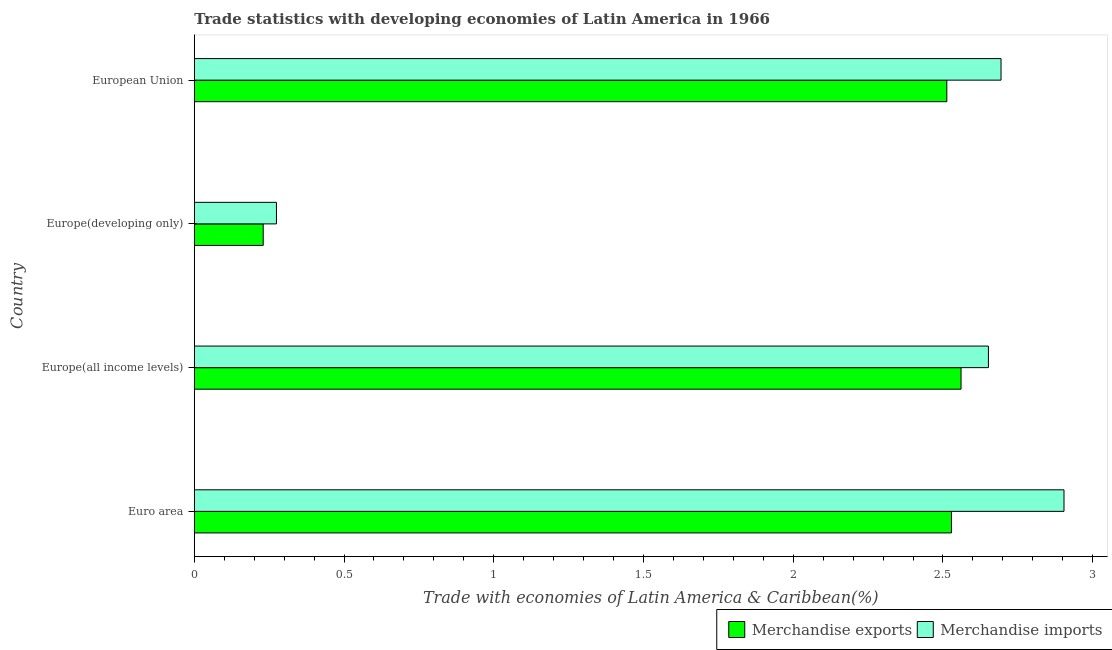Are the number of bars per tick equal to the number of legend labels?
Offer a very short reply. Yes. How many bars are there on the 3rd tick from the top?
Give a very brief answer. 2. How many bars are there on the 2nd tick from the bottom?
Provide a succinct answer. 2. What is the label of the 3rd group of bars from the top?
Ensure brevity in your answer.  Europe(all income levels). What is the merchandise imports in European Union?
Your answer should be very brief. 2.69. Across all countries, what is the maximum merchandise exports?
Offer a very short reply. 2.56. Across all countries, what is the minimum merchandise imports?
Your answer should be compact. 0.27. In which country was the merchandise exports maximum?
Provide a succinct answer. Europe(all income levels). In which country was the merchandise exports minimum?
Offer a terse response. Europe(developing only). What is the total merchandise exports in the graph?
Ensure brevity in your answer.  7.83. What is the difference between the merchandise imports in Europe(developing only) and that in European Union?
Your answer should be compact. -2.42. What is the difference between the merchandise exports in Europe(developing only) and the merchandise imports in Euro area?
Give a very brief answer. -2.67. What is the average merchandise imports per country?
Provide a succinct answer. 2.13. What is the difference between the merchandise exports and merchandise imports in Euro area?
Provide a succinct answer. -0.38. What is the ratio of the merchandise imports in Europe(developing only) to that in European Union?
Your answer should be very brief. 0.1. Is the difference between the merchandise imports in Euro area and European Union greater than the difference between the merchandise exports in Euro area and European Union?
Make the answer very short. Yes. What is the difference between the highest and the second highest merchandise imports?
Offer a terse response. 0.21. What is the difference between the highest and the lowest merchandise imports?
Give a very brief answer. 2.63. What does the 1st bar from the top in Europe(all income levels) represents?
Your answer should be compact. Merchandise imports. Are all the bars in the graph horizontal?
Offer a very short reply. Yes. How many countries are there in the graph?
Keep it short and to the point. 4. What is the difference between two consecutive major ticks on the X-axis?
Your answer should be compact. 0.5. Are the values on the major ticks of X-axis written in scientific E-notation?
Give a very brief answer. No. Does the graph contain any zero values?
Your answer should be very brief. No. Does the graph contain grids?
Offer a terse response. No. Where does the legend appear in the graph?
Offer a very short reply. Bottom right. How many legend labels are there?
Give a very brief answer. 2. What is the title of the graph?
Give a very brief answer. Trade statistics with developing economies of Latin America in 1966. What is the label or title of the X-axis?
Your response must be concise. Trade with economies of Latin America & Caribbean(%). What is the label or title of the Y-axis?
Your answer should be compact. Country. What is the Trade with economies of Latin America & Caribbean(%) in Merchandise exports in Euro area?
Your answer should be compact. 2.53. What is the Trade with economies of Latin America & Caribbean(%) of Merchandise imports in Euro area?
Your response must be concise. 2.9. What is the Trade with economies of Latin America & Caribbean(%) in Merchandise exports in Europe(all income levels)?
Make the answer very short. 2.56. What is the Trade with economies of Latin America & Caribbean(%) of Merchandise imports in Europe(all income levels)?
Your answer should be compact. 2.65. What is the Trade with economies of Latin America & Caribbean(%) of Merchandise exports in Europe(developing only)?
Your response must be concise. 0.23. What is the Trade with economies of Latin America & Caribbean(%) of Merchandise imports in Europe(developing only)?
Keep it short and to the point. 0.27. What is the Trade with economies of Latin America & Caribbean(%) in Merchandise exports in European Union?
Your answer should be very brief. 2.51. What is the Trade with economies of Latin America & Caribbean(%) of Merchandise imports in European Union?
Your answer should be compact. 2.69. Across all countries, what is the maximum Trade with economies of Latin America & Caribbean(%) of Merchandise exports?
Keep it short and to the point. 2.56. Across all countries, what is the maximum Trade with economies of Latin America & Caribbean(%) of Merchandise imports?
Give a very brief answer. 2.9. Across all countries, what is the minimum Trade with economies of Latin America & Caribbean(%) of Merchandise exports?
Your answer should be very brief. 0.23. Across all countries, what is the minimum Trade with economies of Latin America & Caribbean(%) in Merchandise imports?
Keep it short and to the point. 0.27. What is the total Trade with economies of Latin America & Caribbean(%) in Merchandise exports in the graph?
Offer a very short reply. 7.83. What is the total Trade with economies of Latin America & Caribbean(%) of Merchandise imports in the graph?
Offer a very short reply. 8.52. What is the difference between the Trade with economies of Latin America & Caribbean(%) in Merchandise exports in Euro area and that in Europe(all income levels)?
Your answer should be very brief. -0.03. What is the difference between the Trade with economies of Latin America & Caribbean(%) in Merchandise imports in Euro area and that in Europe(all income levels)?
Offer a very short reply. 0.25. What is the difference between the Trade with economies of Latin America & Caribbean(%) in Merchandise exports in Euro area and that in Europe(developing only)?
Your response must be concise. 2.3. What is the difference between the Trade with economies of Latin America & Caribbean(%) of Merchandise imports in Euro area and that in Europe(developing only)?
Keep it short and to the point. 2.63. What is the difference between the Trade with economies of Latin America & Caribbean(%) in Merchandise exports in Euro area and that in European Union?
Offer a very short reply. 0.02. What is the difference between the Trade with economies of Latin America & Caribbean(%) in Merchandise imports in Euro area and that in European Union?
Your answer should be very brief. 0.21. What is the difference between the Trade with economies of Latin America & Caribbean(%) of Merchandise exports in Europe(all income levels) and that in Europe(developing only)?
Make the answer very short. 2.33. What is the difference between the Trade with economies of Latin America & Caribbean(%) in Merchandise imports in Europe(all income levels) and that in Europe(developing only)?
Make the answer very short. 2.38. What is the difference between the Trade with economies of Latin America & Caribbean(%) in Merchandise exports in Europe(all income levels) and that in European Union?
Your response must be concise. 0.05. What is the difference between the Trade with economies of Latin America & Caribbean(%) of Merchandise imports in Europe(all income levels) and that in European Union?
Your response must be concise. -0.04. What is the difference between the Trade with economies of Latin America & Caribbean(%) in Merchandise exports in Europe(developing only) and that in European Union?
Provide a short and direct response. -2.28. What is the difference between the Trade with economies of Latin America & Caribbean(%) in Merchandise imports in Europe(developing only) and that in European Union?
Make the answer very short. -2.42. What is the difference between the Trade with economies of Latin America & Caribbean(%) in Merchandise exports in Euro area and the Trade with economies of Latin America & Caribbean(%) in Merchandise imports in Europe(all income levels)?
Give a very brief answer. -0.12. What is the difference between the Trade with economies of Latin America & Caribbean(%) in Merchandise exports in Euro area and the Trade with economies of Latin America & Caribbean(%) in Merchandise imports in Europe(developing only)?
Give a very brief answer. 2.25. What is the difference between the Trade with economies of Latin America & Caribbean(%) of Merchandise exports in Euro area and the Trade with economies of Latin America & Caribbean(%) of Merchandise imports in European Union?
Offer a terse response. -0.17. What is the difference between the Trade with economies of Latin America & Caribbean(%) in Merchandise exports in Europe(all income levels) and the Trade with economies of Latin America & Caribbean(%) in Merchandise imports in Europe(developing only)?
Keep it short and to the point. 2.29. What is the difference between the Trade with economies of Latin America & Caribbean(%) in Merchandise exports in Europe(all income levels) and the Trade with economies of Latin America & Caribbean(%) in Merchandise imports in European Union?
Your answer should be very brief. -0.13. What is the difference between the Trade with economies of Latin America & Caribbean(%) of Merchandise exports in Europe(developing only) and the Trade with economies of Latin America & Caribbean(%) of Merchandise imports in European Union?
Offer a very short reply. -2.46. What is the average Trade with economies of Latin America & Caribbean(%) of Merchandise exports per country?
Your answer should be very brief. 1.96. What is the average Trade with economies of Latin America & Caribbean(%) in Merchandise imports per country?
Make the answer very short. 2.13. What is the difference between the Trade with economies of Latin America & Caribbean(%) in Merchandise exports and Trade with economies of Latin America & Caribbean(%) in Merchandise imports in Euro area?
Keep it short and to the point. -0.38. What is the difference between the Trade with economies of Latin America & Caribbean(%) in Merchandise exports and Trade with economies of Latin America & Caribbean(%) in Merchandise imports in Europe(all income levels)?
Give a very brief answer. -0.09. What is the difference between the Trade with economies of Latin America & Caribbean(%) of Merchandise exports and Trade with economies of Latin America & Caribbean(%) of Merchandise imports in Europe(developing only)?
Provide a short and direct response. -0.04. What is the difference between the Trade with economies of Latin America & Caribbean(%) in Merchandise exports and Trade with economies of Latin America & Caribbean(%) in Merchandise imports in European Union?
Your answer should be very brief. -0.18. What is the ratio of the Trade with economies of Latin America & Caribbean(%) of Merchandise exports in Euro area to that in Europe(all income levels)?
Make the answer very short. 0.99. What is the ratio of the Trade with economies of Latin America & Caribbean(%) of Merchandise imports in Euro area to that in Europe(all income levels)?
Your answer should be very brief. 1.1. What is the ratio of the Trade with economies of Latin America & Caribbean(%) in Merchandise exports in Euro area to that in Europe(developing only)?
Offer a very short reply. 10.98. What is the ratio of the Trade with economies of Latin America & Caribbean(%) of Merchandise imports in Euro area to that in Europe(developing only)?
Offer a very short reply. 10.58. What is the ratio of the Trade with economies of Latin America & Caribbean(%) in Merchandise exports in Euro area to that in European Union?
Offer a very short reply. 1.01. What is the ratio of the Trade with economies of Latin America & Caribbean(%) in Merchandise imports in Euro area to that in European Union?
Provide a short and direct response. 1.08. What is the ratio of the Trade with economies of Latin America & Caribbean(%) in Merchandise exports in Europe(all income levels) to that in Europe(developing only)?
Your answer should be very brief. 11.12. What is the ratio of the Trade with economies of Latin America & Caribbean(%) of Merchandise imports in Europe(all income levels) to that in Europe(developing only)?
Ensure brevity in your answer.  9.66. What is the ratio of the Trade with economies of Latin America & Caribbean(%) in Merchandise exports in Europe(all income levels) to that in European Union?
Offer a very short reply. 1.02. What is the ratio of the Trade with economies of Latin America & Caribbean(%) in Merchandise imports in Europe(all income levels) to that in European Union?
Ensure brevity in your answer.  0.98. What is the ratio of the Trade with economies of Latin America & Caribbean(%) in Merchandise exports in Europe(developing only) to that in European Union?
Keep it short and to the point. 0.09. What is the ratio of the Trade with economies of Latin America & Caribbean(%) in Merchandise imports in Europe(developing only) to that in European Union?
Your response must be concise. 0.1. What is the difference between the highest and the second highest Trade with economies of Latin America & Caribbean(%) of Merchandise exports?
Provide a short and direct response. 0.03. What is the difference between the highest and the second highest Trade with economies of Latin America & Caribbean(%) in Merchandise imports?
Give a very brief answer. 0.21. What is the difference between the highest and the lowest Trade with economies of Latin America & Caribbean(%) of Merchandise exports?
Provide a short and direct response. 2.33. What is the difference between the highest and the lowest Trade with economies of Latin America & Caribbean(%) in Merchandise imports?
Ensure brevity in your answer.  2.63. 